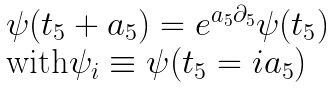Convert formula to latex. <formula><loc_0><loc_0><loc_500><loc_500>\begin{array} { l } \psi ( t _ { 5 } + a _ { 5 } ) = e ^ { a _ { 5 } \partial _ { 5 } } \psi ( t _ { 5 } ) \\ \text {with} \psi _ { i } \equiv \psi ( t _ { 5 } = i a _ { 5 } ) \end{array}</formula> 